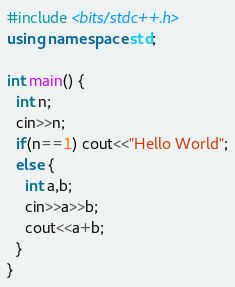Convert code to text. <code><loc_0><loc_0><loc_500><loc_500><_C++_>#include <bits/stdc++.h>
using namespace std;

int main() {
  int n;
  cin>>n;
  if(n==1) cout<<"Hello World";
  else {
    int a,b;
    cin>>a>>b;
    cout<<a+b;
  }
}
</code> 